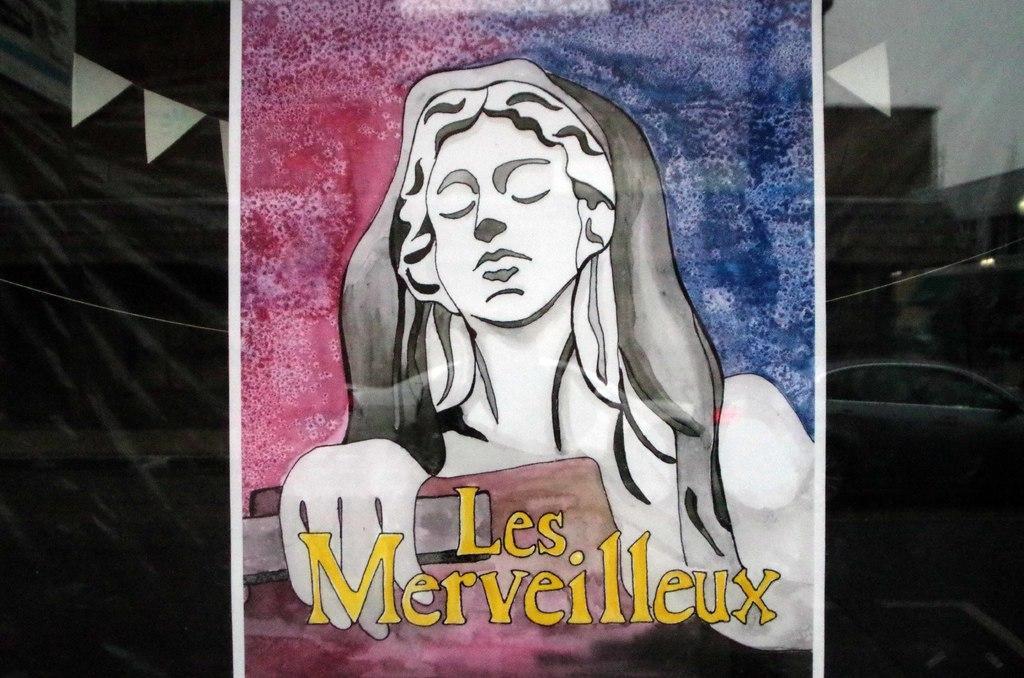How would you summarize this image in a sentence or two? In the picture we can see a painting of a woman and written on it as les merveilleux and behind the painting we can see a black color curtain. 